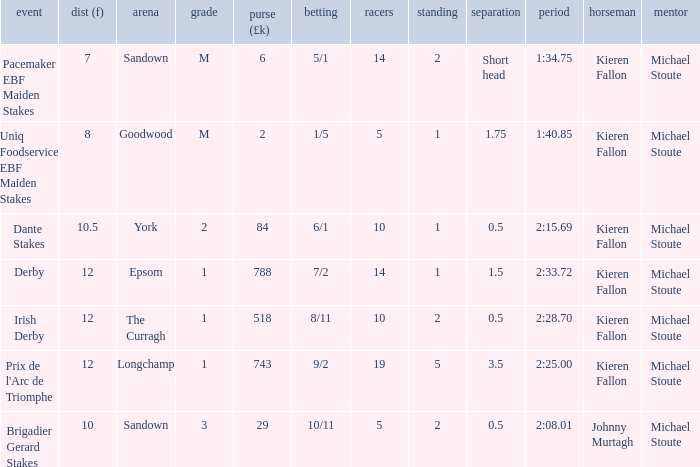Name the least runners with dist of 10.5 10.0. 